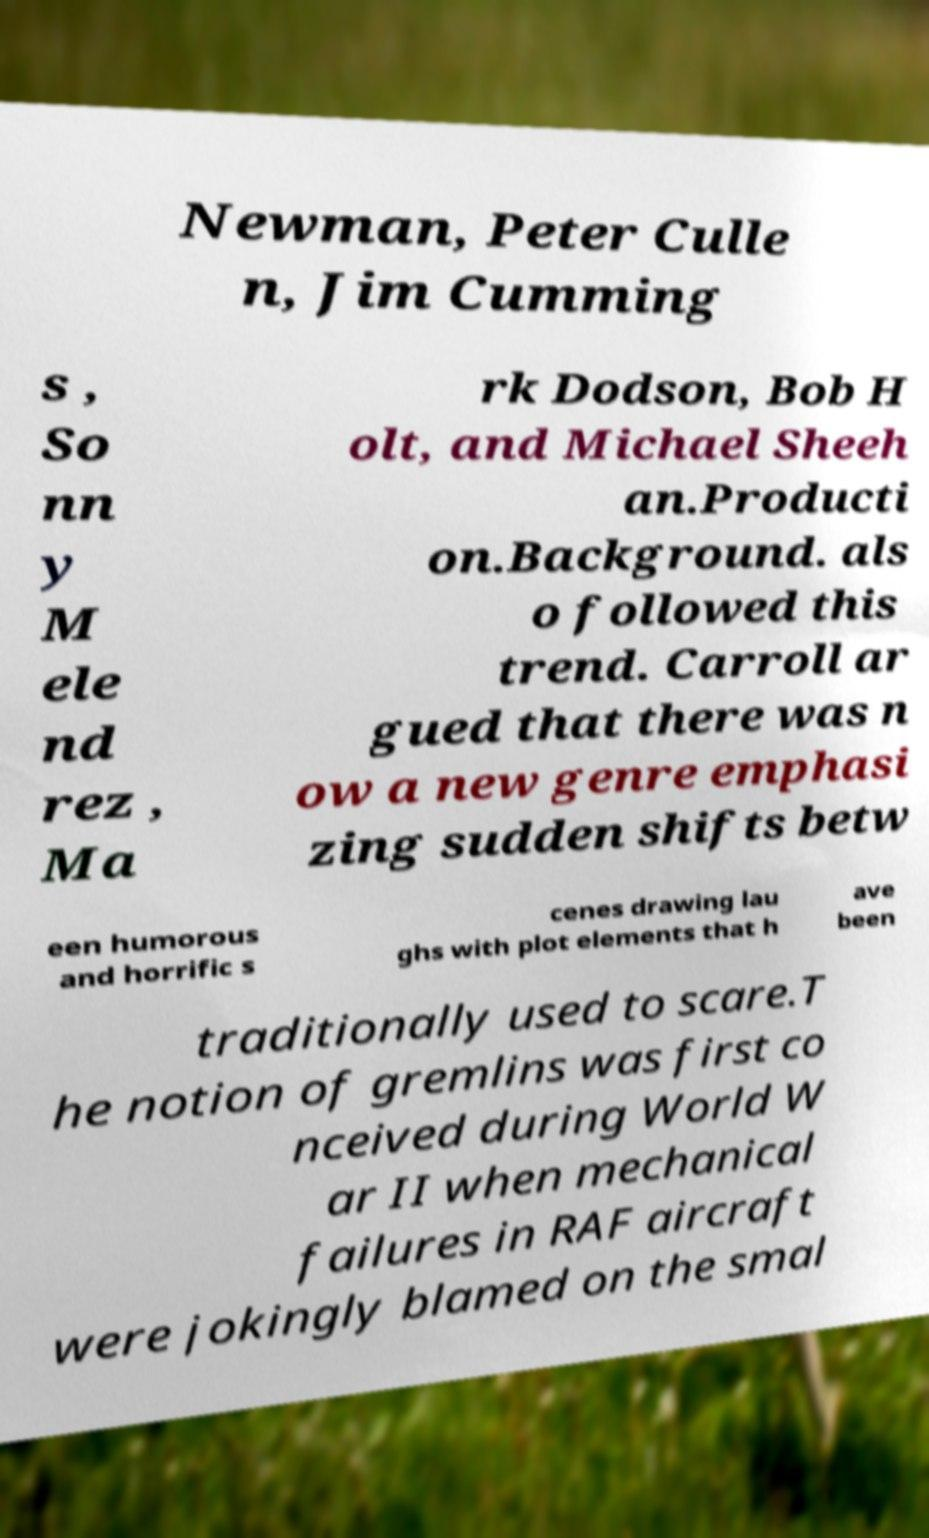I need the written content from this picture converted into text. Can you do that? Newman, Peter Culle n, Jim Cumming s , So nn y M ele nd rez , Ma rk Dodson, Bob H olt, and Michael Sheeh an.Producti on.Background. als o followed this trend. Carroll ar gued that there was n ow a new genre emphasi zing sudden shifts betw een humorous and horrific s cenes drawing lau ghs with plot elements that h ave been traditionally used to scare.T he notion of gremlins was first co nceived during World W ar II when mechanical failures in RAF aircraft were jokingly blamed on the smal 